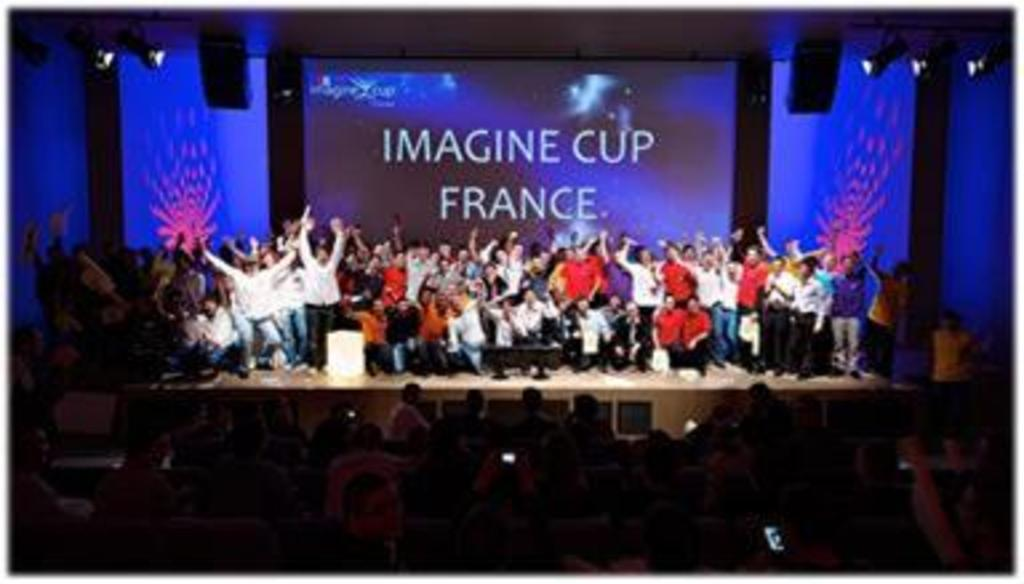What can be seen in the image? There are groups of people in the image. What is behind the people? There are screens behind the people. What is present at the top of the image? There are lights and objects at the top of the image. Can you hear the people in the image having a discussion about a bike? There is no audio in the image, so it is not possible to hear any discussions or topics being discussed. 